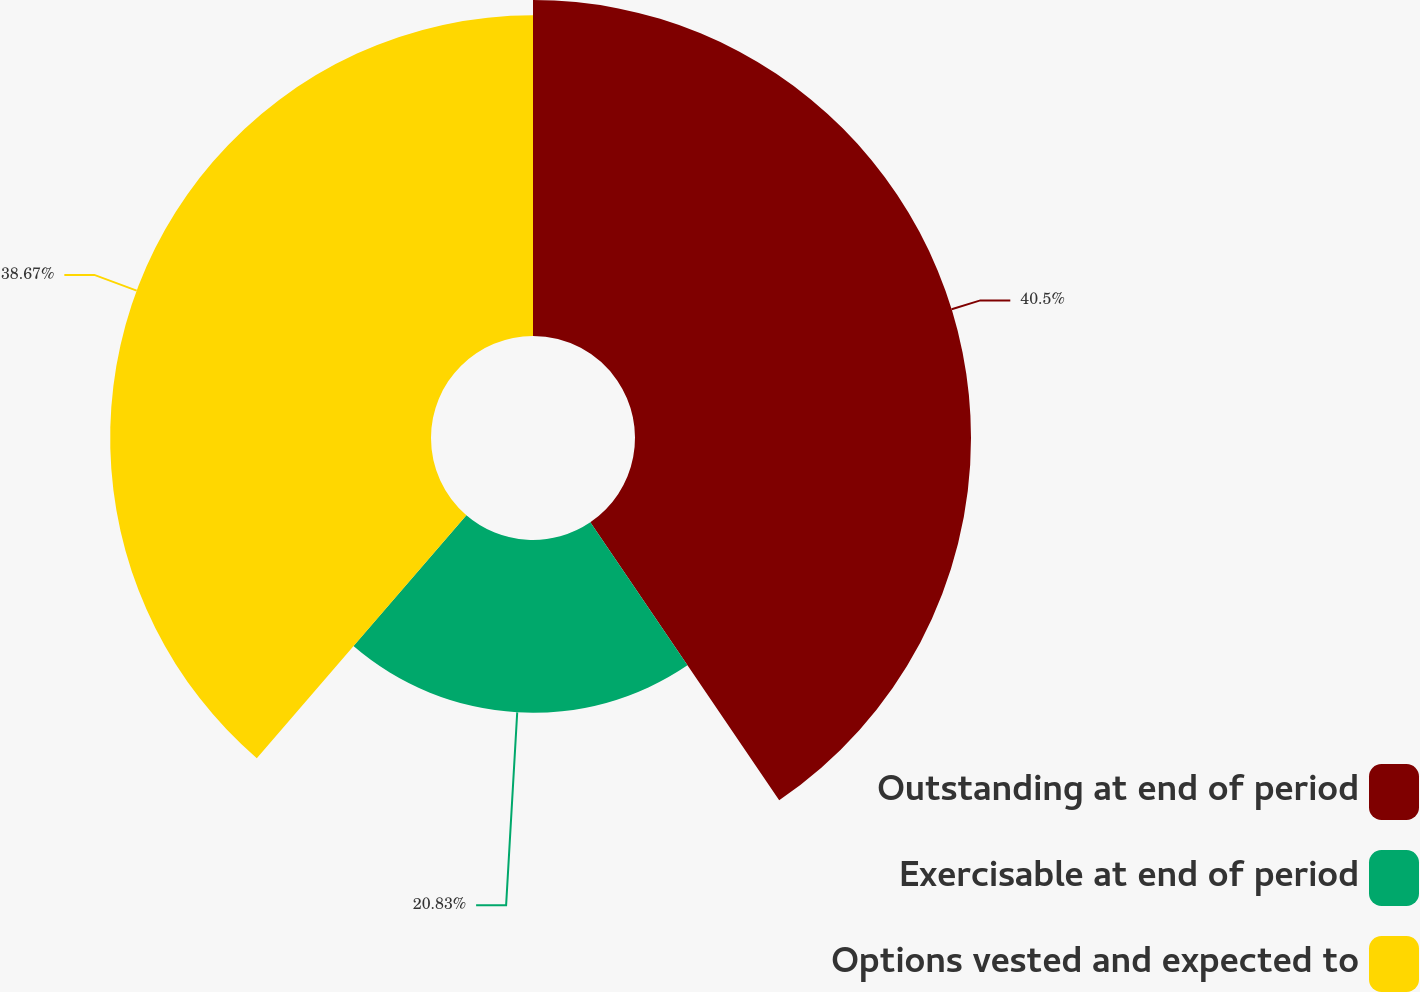<chart> <loc_0><loc_0><loc_500><loc_500><pie_chart><fcel>Outstanding at end of period<fcel>Exercisable at end of period<fcel>Options vested and expected to<nl><fcel>40.5%<fcel>20.83%<fcel>38.67%<nl></chart> 